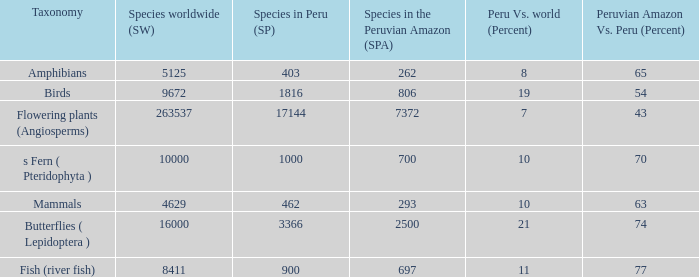What's the total number of species in the peruvian amazon with 8411 species in the world  1.0. 